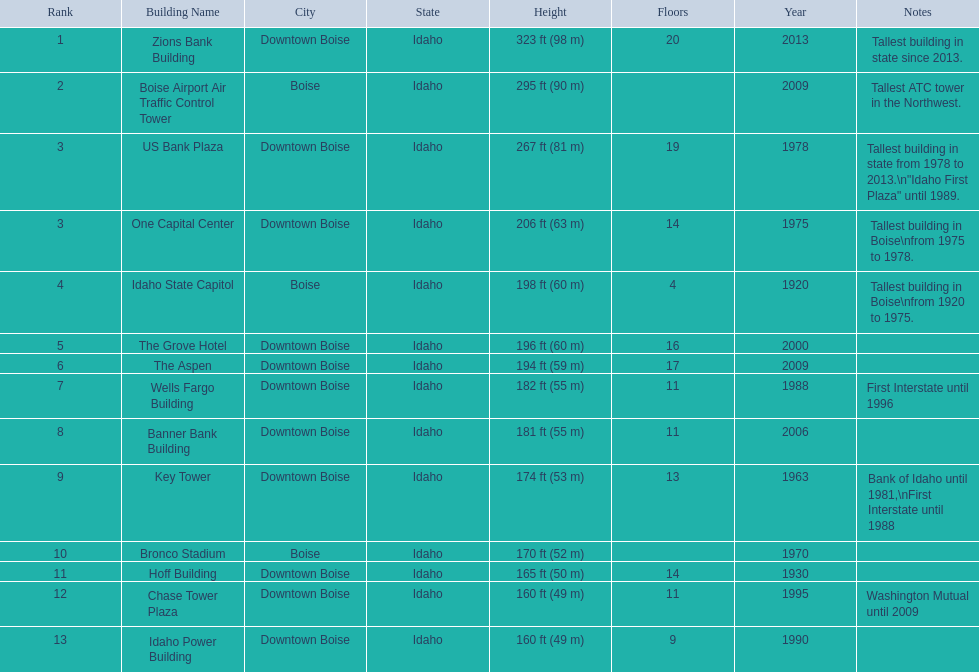Parse the table in full. {'header': ['Rank', 'Building Name', 'City', 'State', 'Height', 'Floors', 'Year', 'Notes'], 'rows': [['1', 'Zions Bank Building', 'Downtown Boise', 'Idaho', '323\xa0ft (98\xa0m)', '20', '2013', 'Tallest building in state since 2013.'], ['2', 'Boise Airport Air Traffic Control Tower', 'Boise', 'Idaho', '295\xa0ft (90\xa0m)', '', '2009', 'Tallest ATC tower in the Northwest.'], ['3', 'US Bank Plaza', 'Downtown Boise', 'Idaho', '267\xa0ft (81\xa0m)', '19', '1978', 'Tallest building in state from 1978 to 2013.\\n"Idaho First Plaza" until 1989.'], ['3', 'One Capital Center', 'Downtown Boise', 'Idaho', '206\xa0ft (63\xa0m)', '14', '1975', 'Tallest building in Boise\\nfrom 1975 to 1978.'], ['4', 'Idaho State Capitol', 'Boise', 'Idaho', '198\xa0ft (60\xa0m)', '4', '1920', 'Tallest building in Boise\\nfrom 1920 to 1975.'], ['5', 'The Grove Hotel', 'Downtown Boise', 'Idaho', '196\xa0ft (60\xa0m)', '16', '2000', ''], ['6', 'The Aspen', 'Downtown Boise', 'Idaho', '194\xa0ft (59\xa0m)', '17', '2009', ''], ['7', 'Wells Fargo Building', 'Downtown Boise', 'Idaho', '182\xa0ft (55\xa0m)', '11', '1988', 'First Interstate until 1996'], ['8', 'Banner Bank Building', 'Downtown Boise', 'Idaho', '181\xa0ft (55\xa0m)', '11', '2006', ''], ['9', 'Key Tower', 'Downtown Boise', 'Idaho', '174\xa0ft (53\xa0m)', '13', '1963', 'Bank of Idaho until 1981,\\nFirst Interstate until 1988'], ['10', 'Bronco Stadium', 'Boise', 'Idaho', '170\xa0ft (52\xa0m)', '', '1970', ''], ['11', 'Hoff Building', 'Downtown Boise', 'Idaho', '165\xa0ft (50\xa0m)', '14', '1930', ''], ['12', 'Chase Tower Plaza', 'Downtown Boise', 'Idaho', '160\xa0ft (49\xa0m)', '11', '1995', 'Washington Mutual until 2009'], ['13', 'Idaho Power Building', 'Downtown Boise', 'Idaho', '160\xa0ft (49\xa0m)', '9', '1990', '']]} Which building has the most floors according to this chart? Zions Bank Building. 